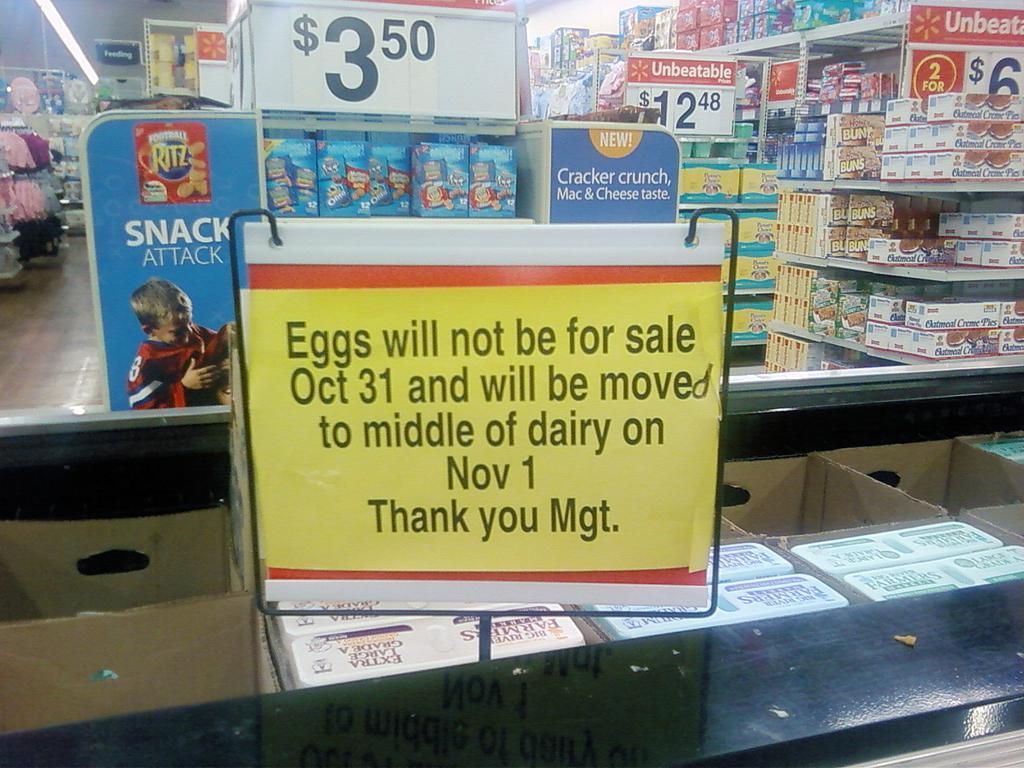Please provide a concise description of this image. In this image I can see the board and the cardboard boxes. In the background I can see many colorful boxes in the racks. I can also see the boards and the lights. 